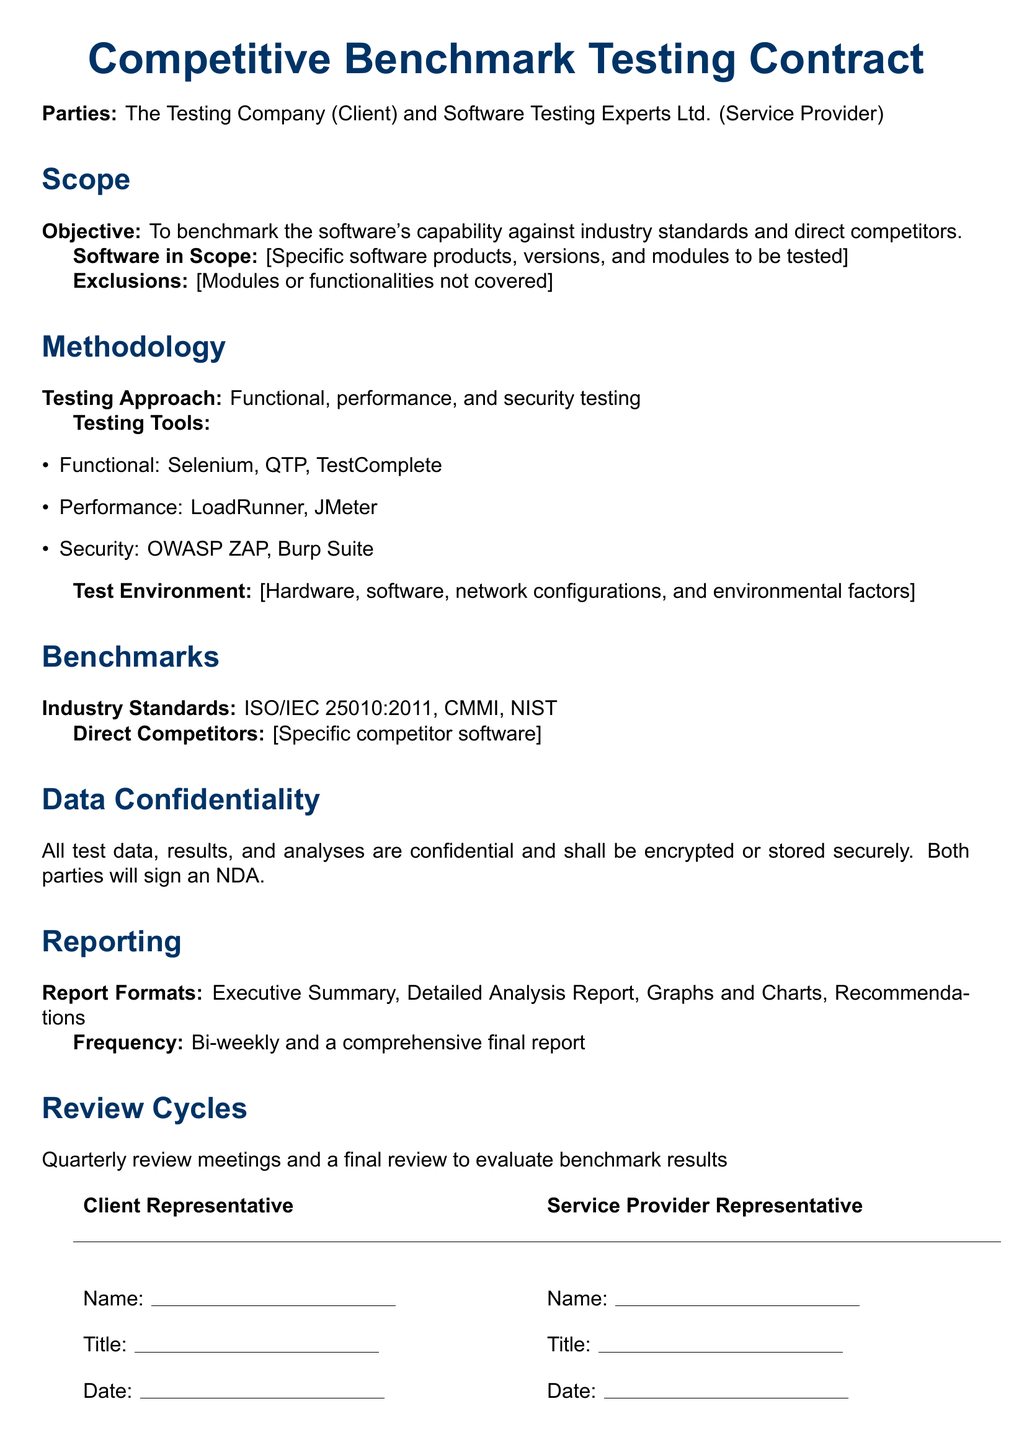What is the objective of the contract? The objective is explicitly stated in the Scope section of the contract, which outlines the goal of benchmarking the software against industry standards and competitors.
Answer: To benchmark the software's capability against industry standards and direct competitors What types of testing are included in the methodology? The methodology section lists the approaches to be used for testing, covering different aspects such as functional, performance, and security testing.
Answer: Functional, performance, and security testing Which testing tools are used for performance testing? The list of testing tools in the Methodology section specifies tools used for different testing types, including LoadRunner and JMeter for performance testing.
Answer: LoadRunner, JMeter What is the frequency of reporting defined in the contract? The Reporting section specifies how often the reports will be generated, which includes bi-weekly and a final comprehensive report.
Answer: Bi-weekly and a comprehensive final report What is the defined standard for data confidentiality? The Data Confidentiality section describes the expected treatment of confidential data, emphasizing encryption and signing of an NDA.
Answer: Encrypted or stored securely; NDA What is one of the industry standards mentioned in the benchmarks? The Benchmarks section lists industry standards relevant to the testing, including ISO/IEC 25010:2011.
Answer: ISO/IEC 25010:2011 How often are review meetings held according to the contract? The Review Cycles section indicates the schedule for review meetings, stating quarterly and a final review.
Answer: Quarterly review meetings Who are the parties involved in the contract? The introduction of the document specifies the parties involved, listing the Testing Company as the Client and Software Testing Experts Ltd. as the Service Provider.
Answer: The Testing Company (Client) and Software Testing Experts Ltd. (Service Provider) 